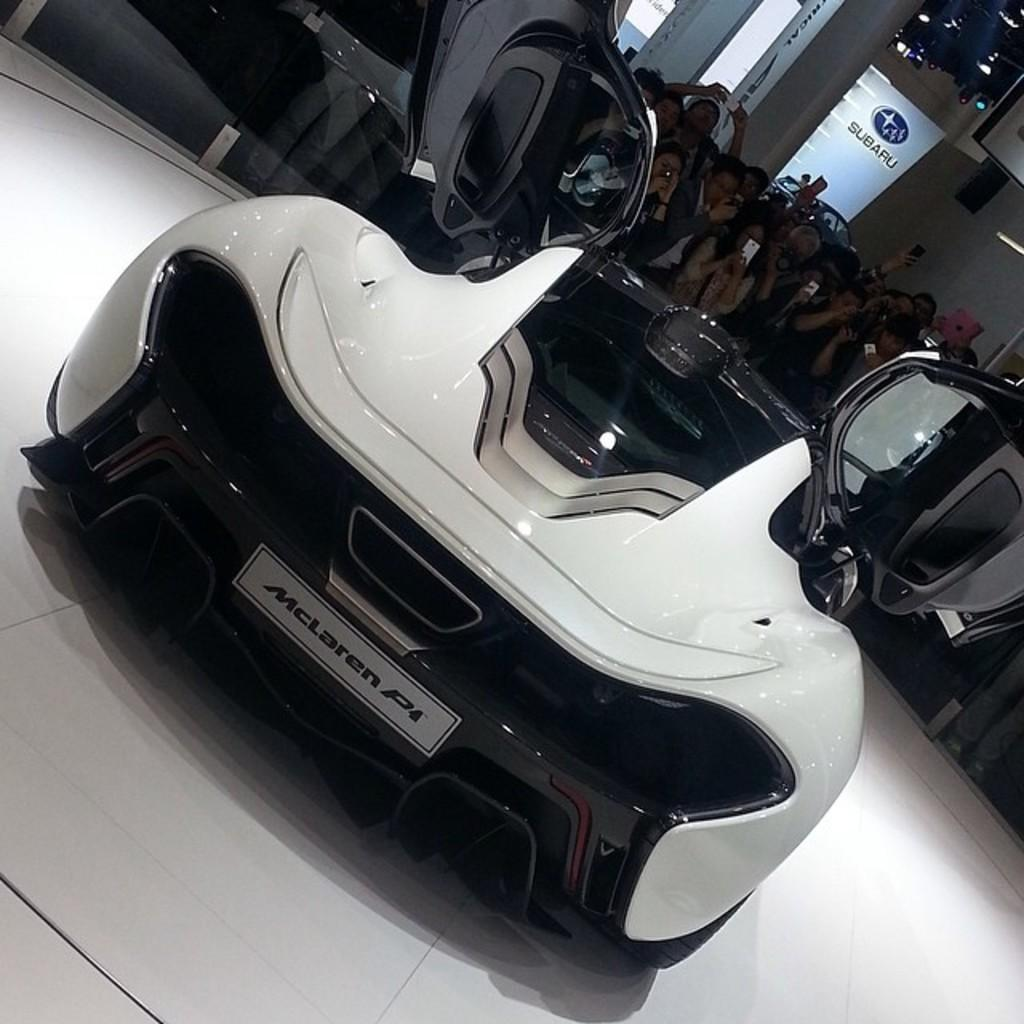What type of vehicle is in the image? There is a white car in the image. What is the state of the car's door? The car's door is open. What can be seen on a plate in the image? There is a plate with writing in the image. What are the people in the background doing? There are many people holding mobiles in the background. What is present in the background along with the people? There is a banner with light in the background. What type of knee injury can be seen in the image? There is no knee injury present in the image. What muscle is being exercised by the person in the image? There is no person exercising a muscle in the image. What type of oven is visible in the image? There is no oven present in the image. 